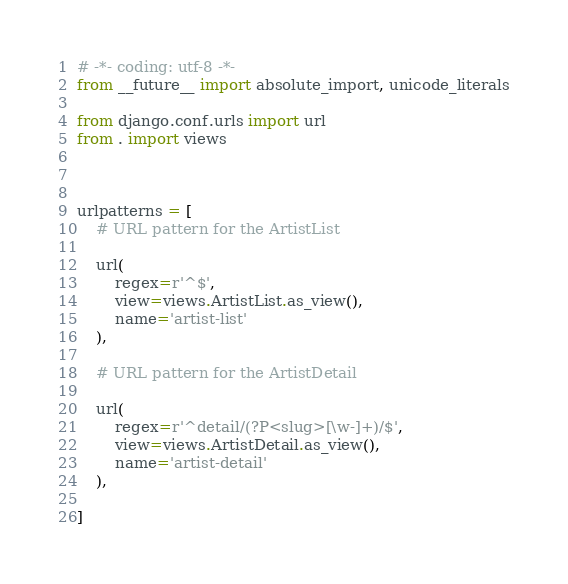Convert code to text. <code><loc_0><loc_0><loc_500><loc_500><_Python_># -*- coding: utf-8 -*-
from __future__ import absolute_import, unicode_literals

from django.conf.urls import url
from . import views



urlpatterns = [
    # URL pattern for the ArtistList

    url(
        regex=r'^$',
        view=views.ArtistList.as_view(),
        name='artist-list'
    ),

    # URL pattern for the ArtistDetail

    url(
        regex=r'^detail/(?P<slug>[\w-]+)/$',
        view=views.ArtistDetail.as_view(),
        name='artist-detail'
    ),

]
</code> 